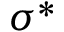Convert formula to latex. <formula><loc_0><loc_0><loc_500><loc_500>\sigma ^ { * }</formula> 